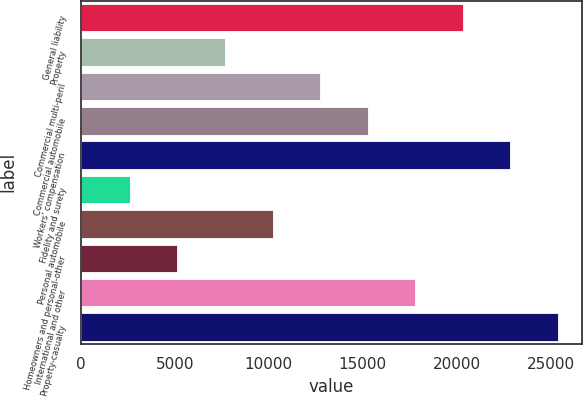Convert chart. <chart><loc_0><loc_0><loc_500><loc_500><bar_chart><fcel>General liability<fcel>Property<fcel>Commercial multi-peril<fcel>Commercial automobile<fcel>Workers' compensation<fcel>Fidelity and surety<fcel>Personal automobile<fcel>Homeowners and personal-other<fcel>International and other<fcel>Property-casualty<nl><fcel>20329.8<fcel>7661.8<fcel>12729<fcel>15262.6<fcel>22863.4<fcel>2594.6<fcel>10195.4<fcel>5128.2<fcel>17796.2<fcel>25397<nl></chart> 